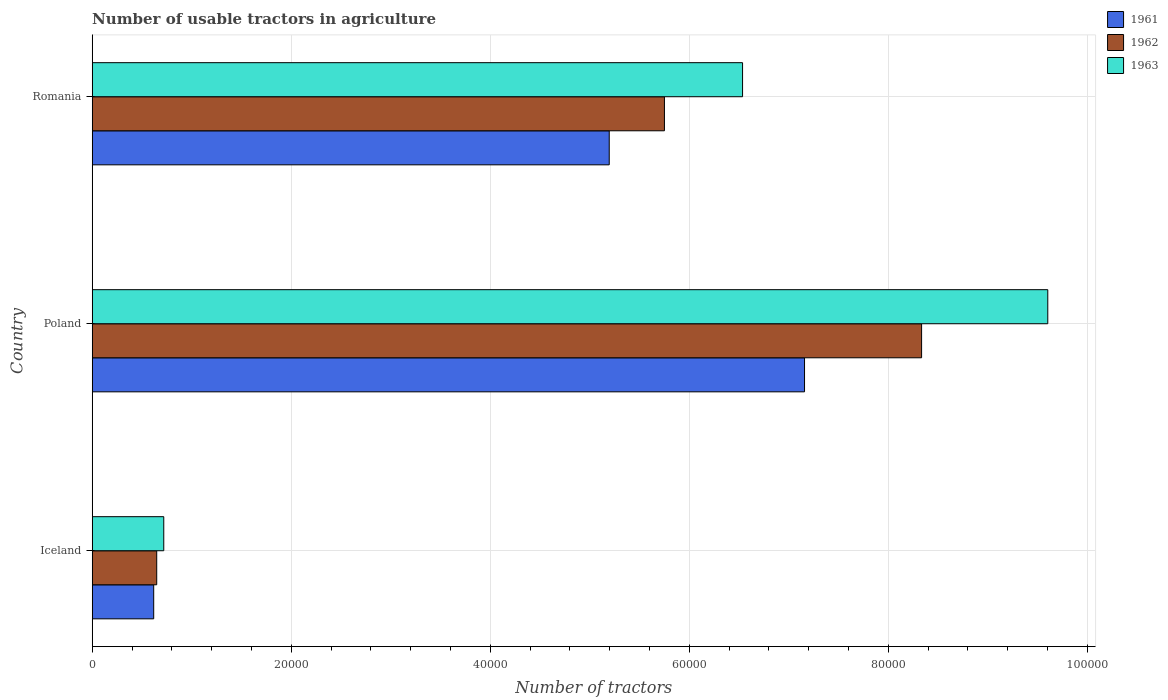How many different coloured bars are there?
Offer a very short reply. 3. Are the number of bars per tick equal to the number of legend labels?
Provide a short and direct response. Yes. What is the label of the 2nd group of bars from the top?
Provide a short and direct response. Poland. In how many cases, is the number of bars for a given country not equal to the number of legend labels?
Make the answer very short. 0. What is the number of usable tractors in agriculture in 1963 in Iceland?
Provide a short and direct response. 7187. Across all countries, what is the maximum number of usable tractors in agriculture in 1961?
Give a very brief answer. 7.16e+04. Across all countries, what is the minimum number of usable tractors in agriculture in 1963?
Keep it short and to the point. 7187. What is the total number of usable tractors in agriculture in 1963 in the graph?
Make the answer very short. 1.69e+05. What is the difference between the number of usable tractors in agriculture in 1963 in Poland and that in Romania?
Give a very brief answer. 3.07e+04. What is the difference between the number of usable tractors in agriculture in 1961 in Romania and the number of usable tractors in agriculture in 1963 in Poland?
Your answer should be very brief. -4.41e+04. What is the average number of usable tractors in agriculture in 1961 per country?
Offer a very short reply. 4.32e+04. What is the difference between the number of usable tractors in agriculture in 1963 and number of usable tractors in agriculture in 1961 in Romania?
Offer a very short reply. 1.34e+04. In how many countries, is the number of usable tractors in agriculture in 1962 greater than 84000 ?
Make the answer very short. 0. What is the ratio of the number of usable tractors in agriculture in 1962 in Iceland to that in Poland?
Keep it short and to the point. 0.08. Is the difference between the number of usable tractors in agriculture in 1963 in Iceland and Poland greater than the difference between the number of usable tractors in agriculture in 1961 in Iceland and Poland?
Provide a short and direct response. No. What is the difference between the highest and the second highest number of usable tractors in agriculture in 1961?
Give a very brief answer. 1.96e+04. What is the difference between the highest and the lowest number of usable tractors in agriculture in 1963?
Give a very brief answer. 8.88e+04. Is the sum of the number of usable tractors in agriculture in 1963 in Poland and Romania greater than the maximum number of usable tractors in agriculture in 1961 across all countries?
Make the answer very short. Yes. Are all the bars in the graph horizontal?
Give a very brief answer. Yes. What is the difference between two consecutive major ticks on the X-axis?
Your answer should be very brief. 2.00e+04. Are the values on the major ticks of X-axis written in scientific E-notation?
Your answer should be compact. No. Where does the legend appear in the graph?
Your answer should be compact. Top right. How are the legend labels stacked?
Ensure brevity in your answer.  Vertical. What is the title of the graph?
Give a very brief answer. Number of usable tractors in agriculture. Does "2011" appear as one of the legend labels in the graph?
Offer a terse response. No. What is the label or title of the X-axis?
Make the answer very short. Number of tractors. What is the label or title of the Y-axis?
Make the answer very short. Country. What is the Number of tractors in 1961 in Iceland?
Your answer should be compact. 6177. What is the Number of tractors in 1962 in Iceland?
Your response must be concise. 6479. What is the Number of tractors in 1963 in Iceland?
Provide a succinct answer. 7187. What is the Number of tractors of 1961 in Poland?
Ensure brevity in your answer.  7.16e+04. What is the Number of tractors of 1962 in Poland?
Make the answer very short. 8.33e+04. What is the Number of tractors in 1963 in Poland?
Make the answer very short. 9.60e+04. What is the Number of tractors of 1961 in Romania?
Your answer should be compact. 5.20e+04. What is the Number of tractors of 1962 in Romania?
Provide a short and direct response. 5.75e+04. What is the Number of tractors of 1963 in Romania?
Provide a short and direct response. 6.54e+04. Across all countries, what is the maximum Number of tractors in 1961?
Offer a terse response. 7.16e+04. Across all countries, what is the maximum Number of tractors in 1962?
Your answer should be compact. 8.33e+04. Across all countries, what is the maximum Number of tractors in 1963?
Provide a short and direct response. 9.60e+04. Across all countries, what is the minimum Number of tractors of 1961?
Your response must be concise. 6177. Across all countries, what is the minimum Number of tractors of 1962?
Provide a short and direct response. 6479. Across all countries, what is the minimum Number of tractors in 1963?
Keep it short and to the point. 7187. What is the total Number of tractors in 1961 in the graph?
Offer a terse response. 1.30e+05. What is the total Number of tractors of 1962 in the graph?
Provide a short and direct response. 1.47e+05. What is the total Number of tractors of 1963 in the graph?
Give a very brief answer. 1.69e+05. What is the difference between the Number of tractors in 1961 in Iceland and that in Poland?
Provide a succinct answer. -6.54e+04. What is the difference between the Number of tractors in 1962 in Iceland and that in Poland?
Make the answer very short. -7.69e+04. What is the difference between the Number of tractors in 1963 in Iceland and that in Poland?
Offer a terse response. -8.88e+04. What is the difference between the Number of tractors in 1961 in Iceland and that in Romania?
Your response must be concise. -4.58e+04. What is the difference between the Number of tractors of 1962 in Iceland and that in Romania?
Provide a short and direct response. -5.10e+04. What is the difference between the Number of tractors in 1963 in Iceland and that in Romania?
Offer a terse response. -5.82e+04. What is the difference between the Number of tractors in 1961 in Poland and that in Romania?
Your answer should be very brief. 1.96e+04. What is the difference between the Number of tractors in 1962 in Poland and that in Romania?
Your response must be concise. 2.58e+04. What is the difference between the Number of tractors in 1963 in Poland and that in Romania?
Your response must be concise. 3.07e+04. What is the difference between the Number of tractors in 1961 in Iceland and the Number of tractors in 1962 in Poland?
Ensure brevity in your answer.  -7.72e+04. What is the difference between the Number of tractors of 1961 in Iceland and the Number of tractors of 1963 in Poland?
Provide a short and direct response. -8.98e+04. What is the difference between the Number of tractors of 1962 in Iceland and the Number of tractors of 1963 in Poland?
Your response must be concise. -8.95e+04. What is the difference between the Number of tractors of 1961 in Iceland and the Number of tractors of 1962 in Romania?
Your response must be concise. -5.13e+04. What is the difference between the Number of tractors in 1961 in Iceland and the Number of tractors in 1963 in Romania?
Your answer should be very brief. -5.92e+04. What is the difference between the Number of tractors in 1962 in Iceland and the Number of tractors in 1963 in Romania?
Offer a terse response. -5.89e+04. What is the difference between the Number of tractors of 1961 in Poland and the Number of tractors of 1962 in Romania?
Your response must be concise. 1.41e+04. What is the difference between the Number of tractors in 1961 in Poland and the Number of tractors in 1963 in Romania?
Provide a succinct answer. 6226. What is the difference between the Number of tractors in 1962 in Poland and the Number of tractors in 1963 in Romania?
Give a very brief answer. 1.80e+04. What is the average Number of tractors of 1961 per country?
Your answer should be very brief. 4.32e+04. What is the average Number of tractors of 1962 per country?
Provide a succinct answer. 4.91e+04. What is the average Number of tractors in 1963 per country?
Ensure brevity in your answer.  5.62e+04. What is the difference between the Number of tractors of 1961 and Number of tractors of 1962 in Iceland?
Your response must be concise. -302. What is the difference between the Number of tractors of 1961 and Number of tractors of 1963 in Iceland?
Your answer should be very brief. -1010. What is the difference between the Number of tractors of 1962 and Number of tractors of 1963 in Iceland?
Make the answer very short. -708. What is the difference between the Number of tractors of 1961 and Number of tractors of 1962 in Poland?
Your response must be concise. -1.18e+04. What is the difference between the Number of tractors of 1961 and Number of tractors of 1963 in Poland?
Keep it short and to the point. -2.44e+04. What is the difference between the Number of tractors of 1962 and Number of tractors of 1963 in Poland?
Your answer should be very brief. -1.27e+04. What is the difference between the Number of tractors of 1961 and Number of tractors of 1962 in Romania?
Offer a terse response. -5548. What is the difference between the Number of tractors in 1961 and Number of tractors in 1963 in Romania?
Your response must be concise. -1.34e+04. What is the difference between the Number of tractors in 1962 and Number of tractors in 1963 in Romania?
Offer a terse response. -7851. What is the ratio of the Number of tractors in 1961 in Iceland to that in Poland?
Your answer should be compact. 0.09. What is the ratio of the Number of tractors of 1962 in Iceland to that in Poland?
Keep it short and to the point. 0.08. What is the ratio of the Number of tractors in 1963 in Iceland to that in Poland?
Provide a short and direct response. 0.07. What is the ratio of the Number of tractors of 1961 in Iceland to that in Romania?
Give a very brief answer. 0.12. What is the ratio of the Number of tractors of 1962 in Iceland to that in Romania?
Your answer should be compact. 0.11. What is the ratio of the Number of tractors in 1963 in Iceland to that in Romania?
Keep it short and to the point. 0.11. What is the ratio of the Number of tractors in 1961 in Poland to that in Romania?
Your answer should be very brief. 1.38. What is the ratio of the Number of tractors of 1962 in Poland to that in Romania?
Offer a terse response. 1.45. What is the ratio of the Number of tractors of 1963 in Poland to that in Romania?
Give a very brief answer. 1.47. What is the difference between the highest and the second highest Number of tractors in 1961?
Your response must be concise. 1.96e+04. What is the difference between the highest and the second highest Number of tractors in 1962?
Provide a succinct answer. 2.58e+04. What is the difference between the highest and the second highest Number of tractors in 1963?
Make the answer very short. 3.07e+04. What is the difference between the highest and the lowest Number of tractors of 1961?
Make the answer very short. 6.54e+04. What is the difference between the highest and the lowest Number of tractors of 1962?
Provide a succinct answer. 7.69e+04. What is the difference between the highest and the lowest Number of tractors in 1963?
Give a very brief answer. 8.88e+04. 